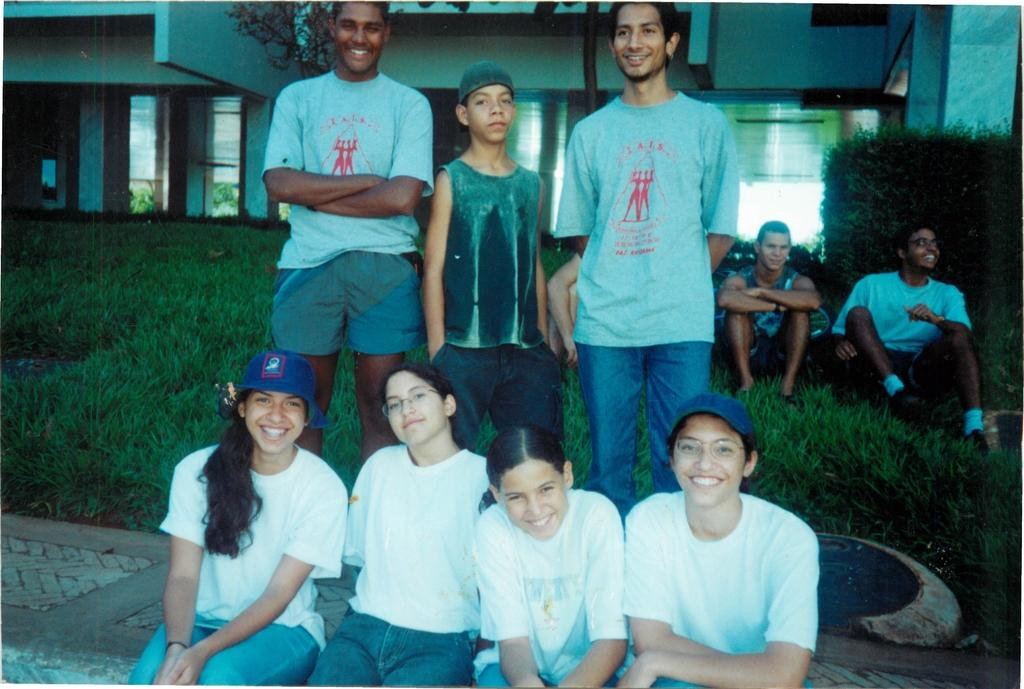How many people are in the image? There is a group of people in the image, but the exact number is not specified. What are the people in the image doing? Some people are seated, while others are standing, and some people are smiling. What can be seen in the background of the image? There is grass, shrubs, and houses in the background of the image. What word is written on the crown that one of the people in the image is wearing? There is no crown present in the image, so it is not possible to answer that question. 